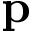<formula> <loc_0><loc_0><loc_500><loc_500>p</formula> 